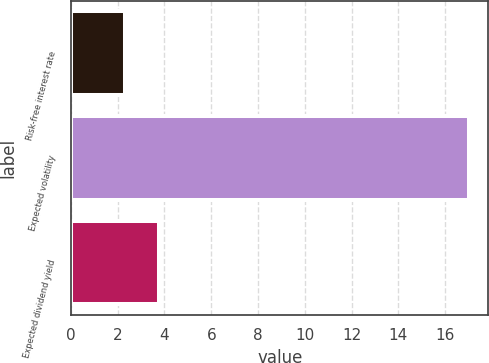Convert chart to OTSL. <chart><loc_0><loc_0><loc_500><loc_500><bar_chart><fcel>Risk-free interest rate<fcel>Expected volatility<fcel>Expected dividend yield<nl><fcel>2.3<fcel>17<fcel>3.77<nl></chart> 